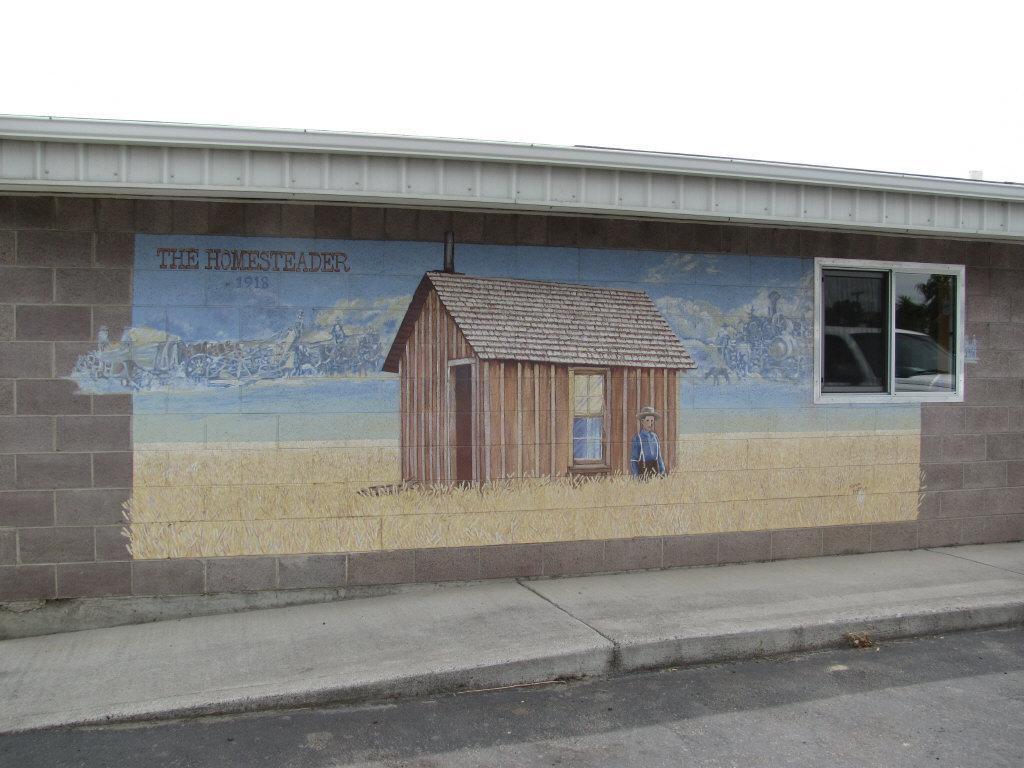Could you give a brief overview of what you see in this image? In this image a wall of the building, with a painting of a person and a house on the grass and text, there is a window to the wall, on the window we can see the reflection of a car and there is a pavement and a road beside the pavement. 